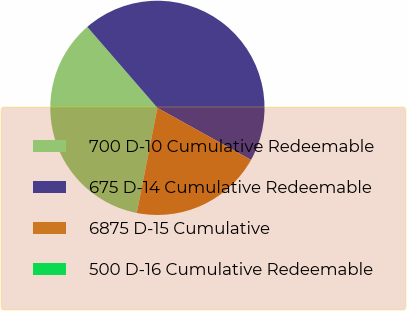<chart> <loc_0><loc_0><loc_500><loc_500><pie_chart><fcel>700 D-10 Cumulative Redeemable<fcel>675 D-14 Cumulative Redeemable<fcel>6875 D-15 Cumulative<fcel>500 D-16 Cumulative Redeemable<nl><fcel>35.56%<fcel>44.44%<fcel>20.0%<fcel>0.0%<nl></chart> 